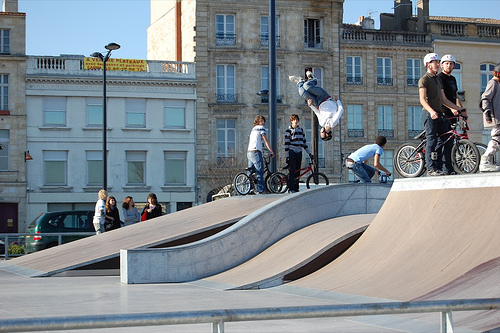<image>
Can you confirm if the boy is on the road? No. The boy is not positioned on the road. They may be near each other, but the boy is not supported by or resting on top of the road. 